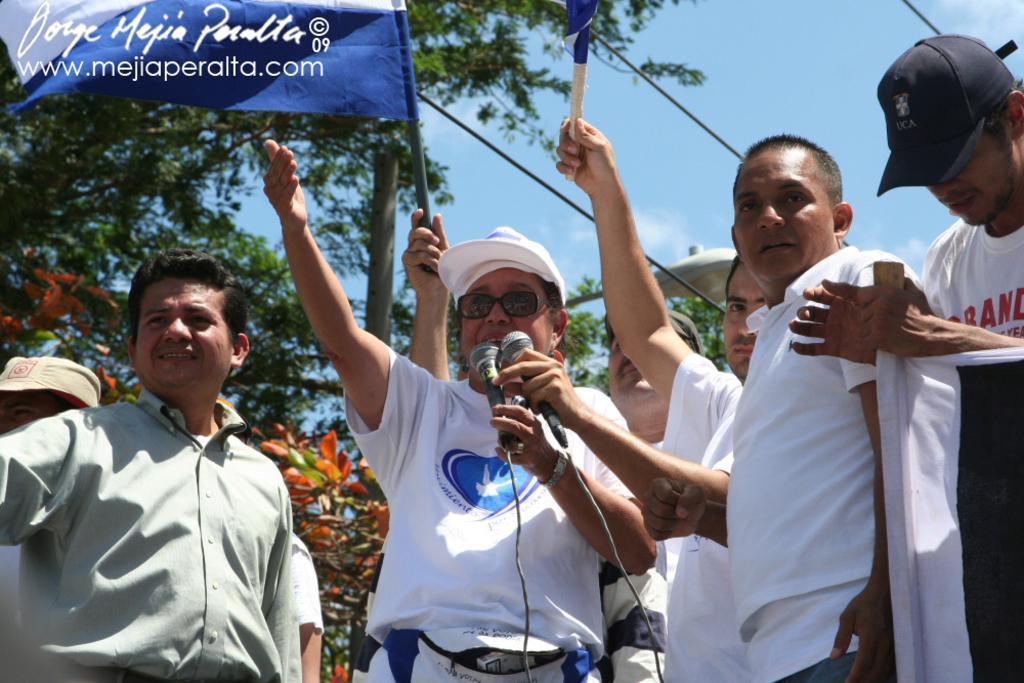Could you give a brief overview of what you see in this image? The man in the middle of the picture wearing a white t-shirt and white cap is holding a microphone in his hand and he is talking on the microphone. Behind him, we see people standing. Behind him, the man wearing a green cap is holding a blue flag in his hand. There are trees in the background and at the top of the picture, we see the sky. 